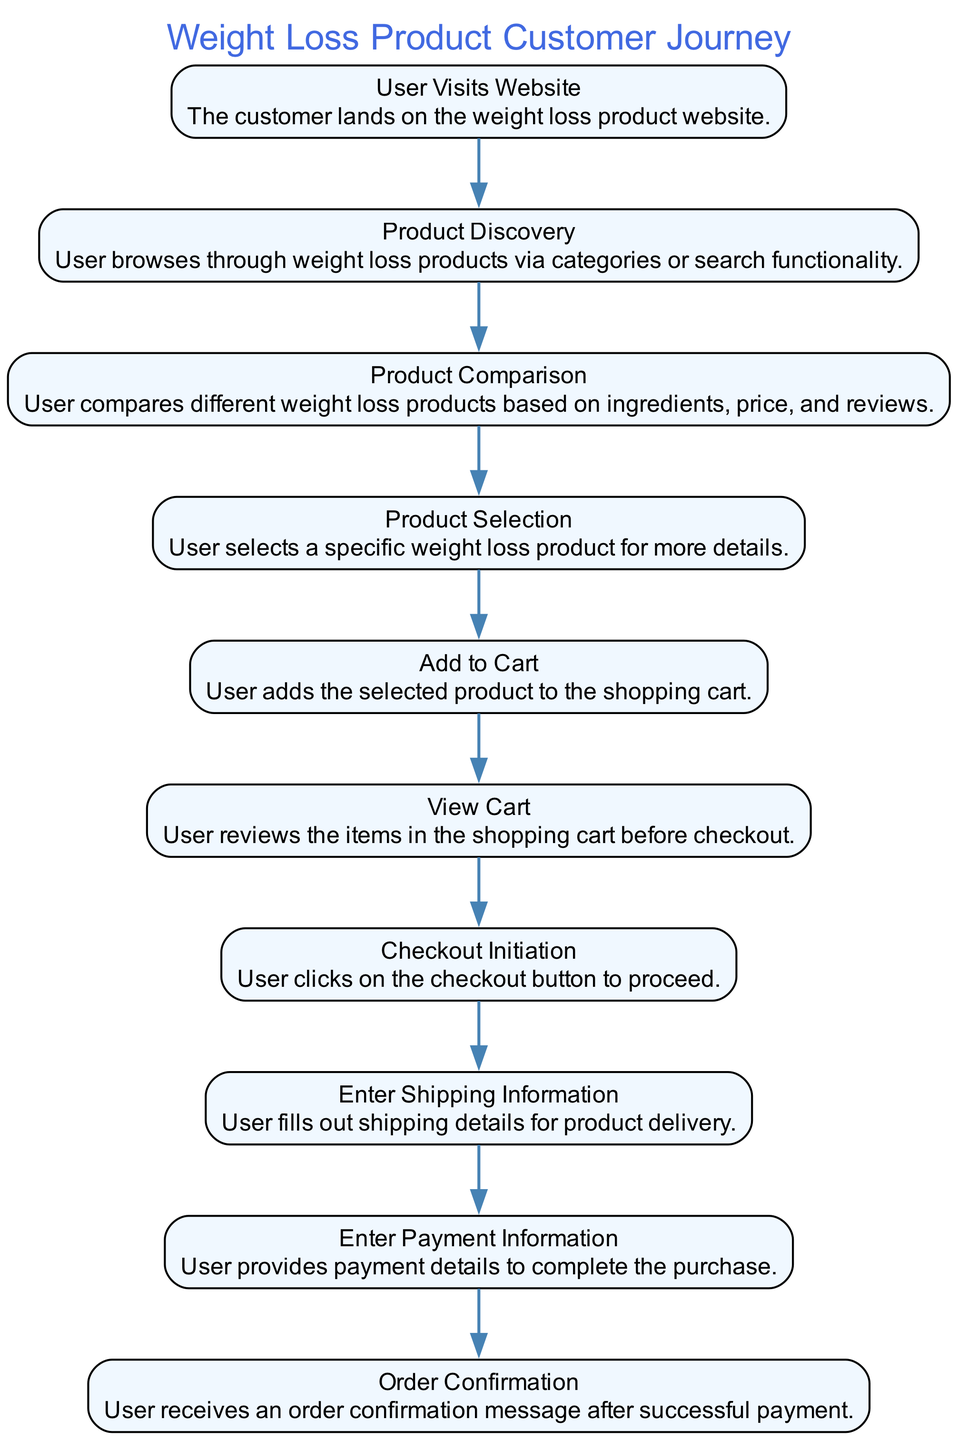What is the total number of steps in the customer journey? The diagram contains ten distinct nodes that represent various steps in the customer journey from product selection to checkout. Each step is clearly listed, starting from "User Visits Website" to "Order Confirmation." Counting these nodes gives a total of ten steps.
Answer: 10 What step comes after "Add to Cart"? Following the "Add to Cart" step, the next node is "View Cart." This is determined by looking at the directed edges in the diagram that show the flow of the customer journey. Hence, it proceeds directly from "Add to Cart" to "View Cart."
Answer: View Cart Which step involves entering payment details? The step that involves entering payment details is "Enter Payment Information." This can be found by referencing the flow of the diagram, particularly after the "Enter Shipping Information" step where the user provides shipping details before moving to payment.
Answer: Enter Payment Information What step directly leads to "Order Confirmation"? The step that directly leads to "Order Confirmation" is "Enter Payment Information." When analyzing the flow, it's evident that the successful provision of payment information leads to receiving an order confirmation, forming a direct connection between the two steps.
Answer: Enter Payment Information Which steps involve user input? The steps that involve user input are "Enter Shipping Information" and "Enter Payment Information." These steps require the customer to actively provide information in order to proceed with the checkout process. This is determined by recognizing that these steps prompt user interaction to enter relevant details.
Answer: Enter Shipping Information, Enter Payment Information What is the first step of the diagram? The first step of the diagram is "User Visits Website." This is the starting point of the customer journey, as depicted at the very top of the sequence, indicating the initiation of the process.
Answer: User Visits Website In what step does the user compare products? The user compares products in the "Product Comparison" step. By following the flow of the diagram, we see that this occurs after product discovery, where the customer browses various options before proceeding to compare them.
Answer: Product Comparison How many edges are in the diagram? There are nine edges in the diagram. Each edge represents a transition from one step to the next, and since there are ten steps, one less than the number of steps gives us the count of the edges connecting these steps in sequence.
Answer: 9 